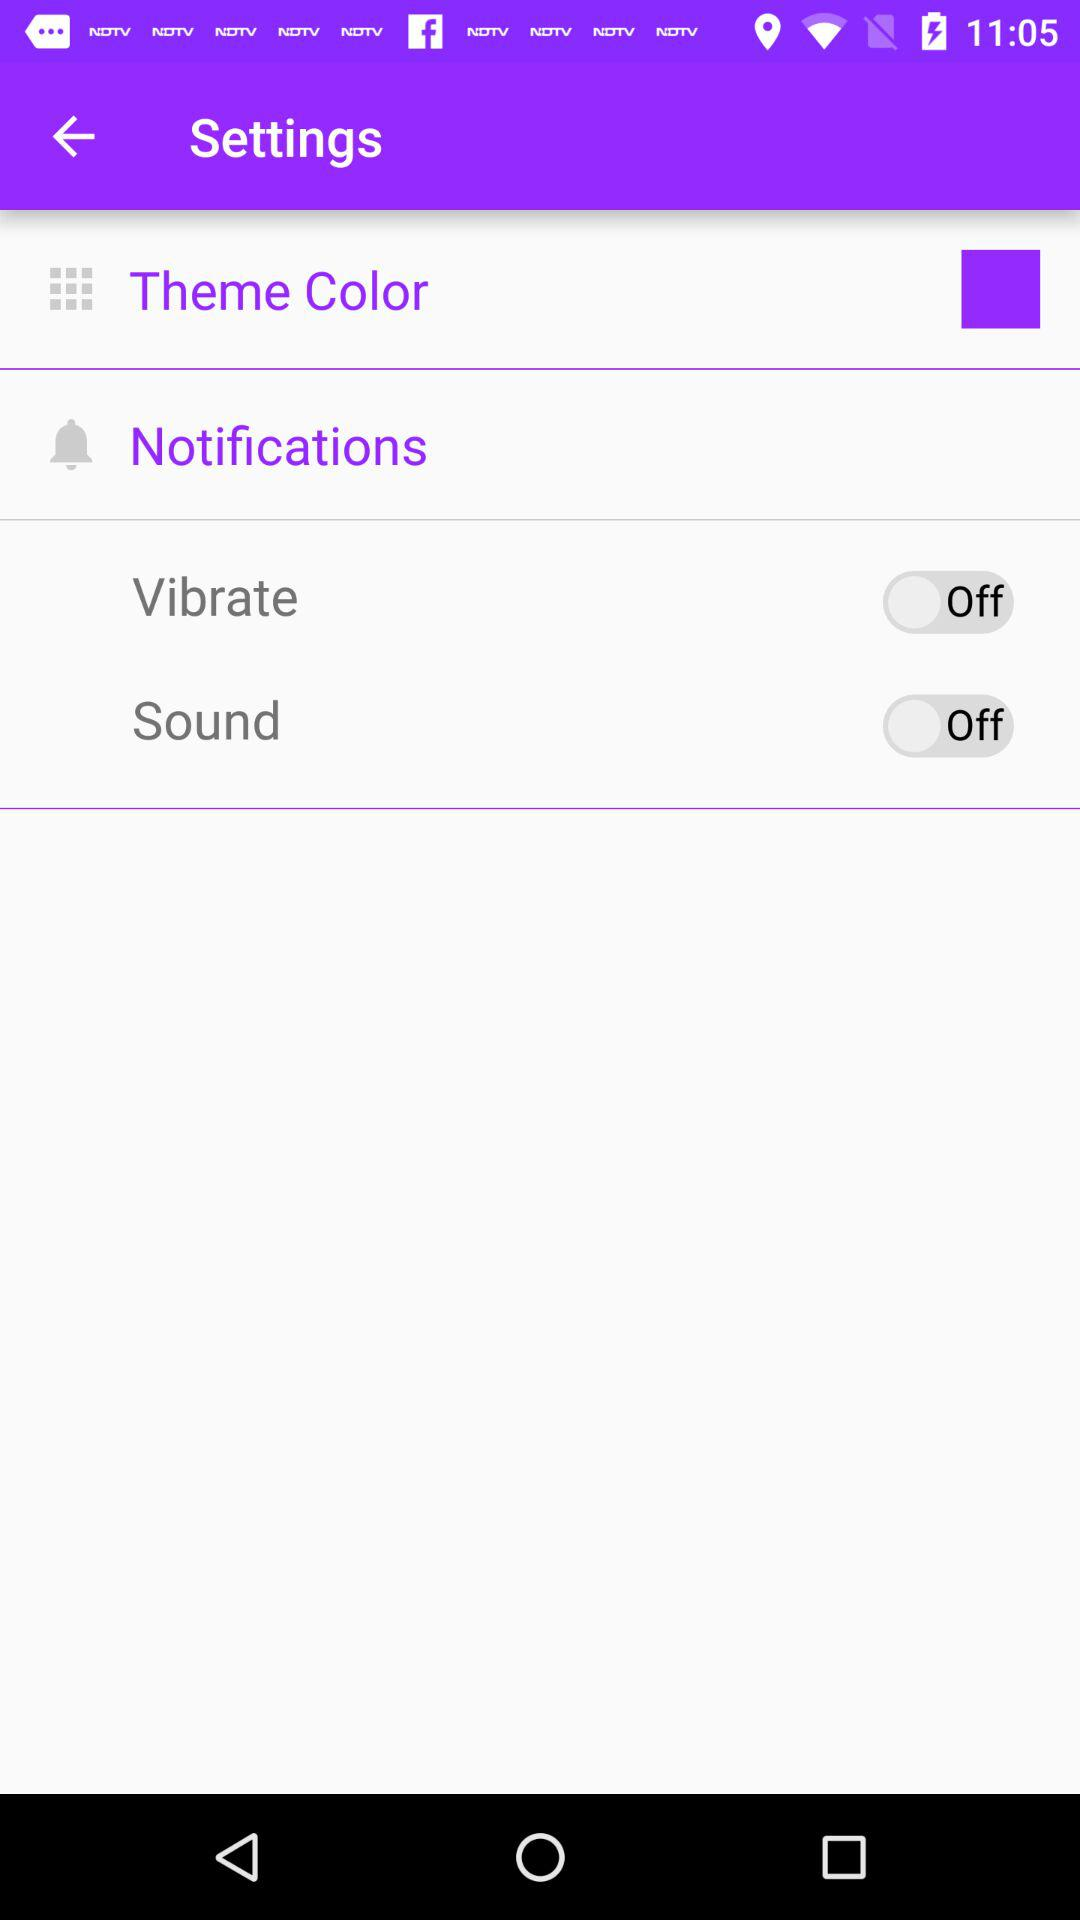What is the status of "Vibrate"? The status of "Vibrate" is "off". 